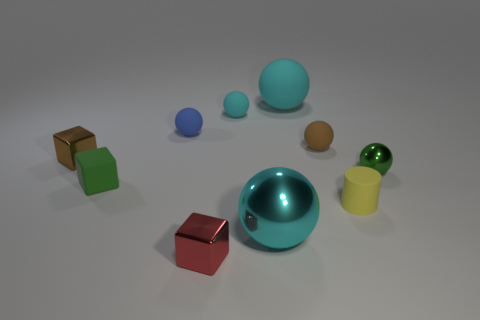How many cyan spheres must be subtracted to get 1 cyan spheres? 2 Subtract all purple cubes. How many cyan balls are left? 3 Subtract 2 balls. How many balls are left? 4 Subtract all cyan balls. How many balls are left? 3 Subtract all brown balls. How many balls are left? 5 Subtract all gray spheres. Subtract all purple blocks. How many spheres are left? 6 Subtract all cubes. How many objects are left? 7 Subtract 0 cyan cubes. How many objects are left? 10 Subtract all cyan metallic objects. Subtract all small balls. How many objects are left? 5 Add 6 small cylinders. How many small cylinders are left? 7 